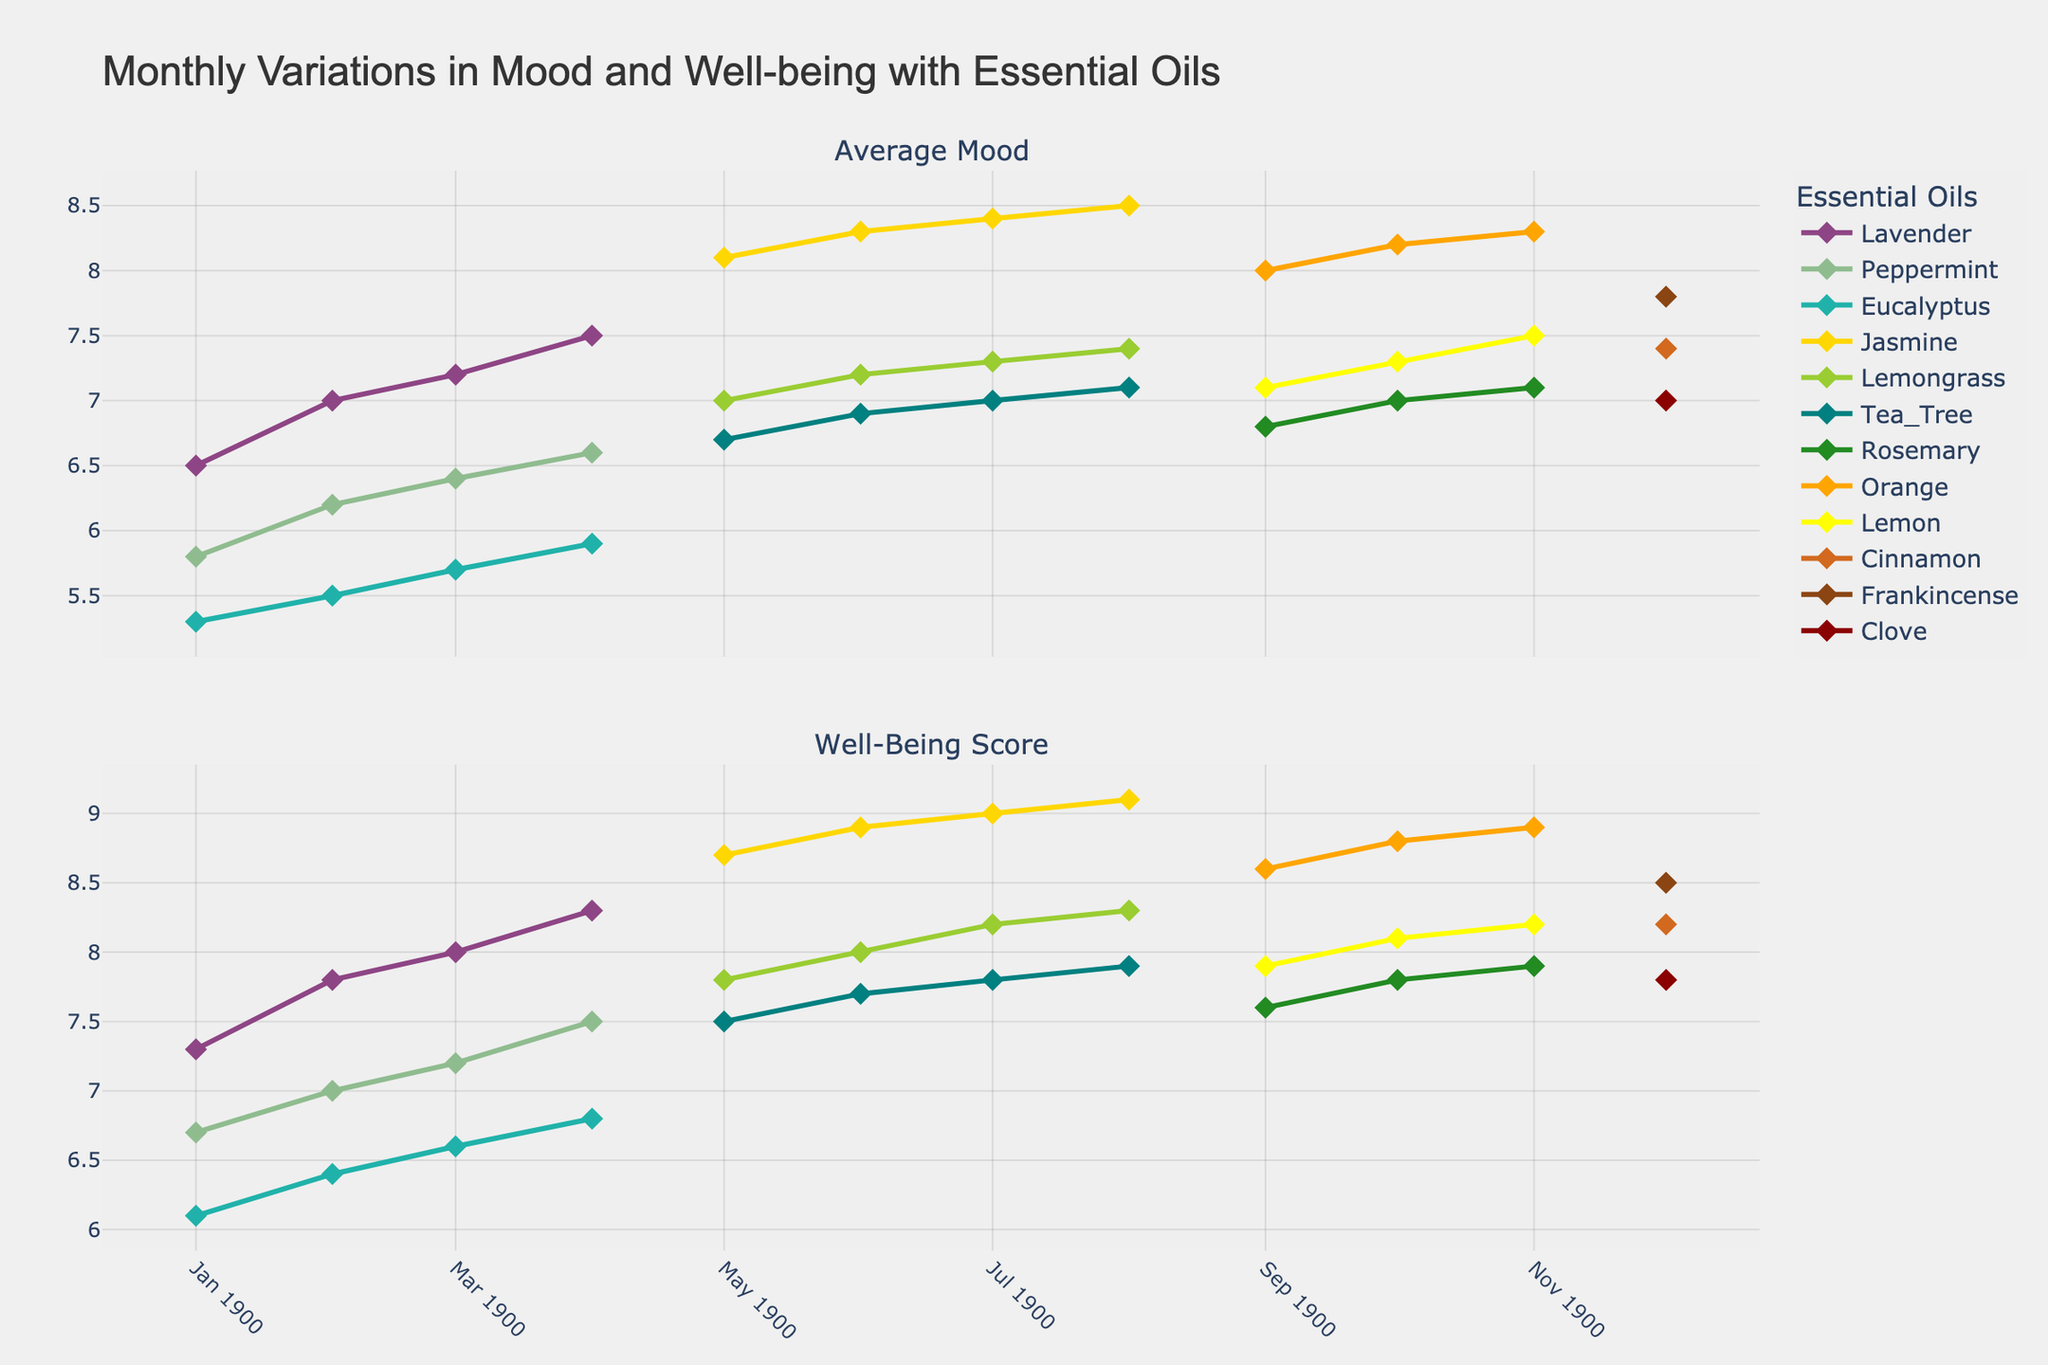Which essential oil has the highest Well-Being Score in August? To find the highest Well-Being Score in August, locate the data for August and compare the Well-Being Scores of "Jasmine," "Lemongrass," and "Tea Tree." Jasmine has the highest score at 9.1.
Answer: Jasmine How does the trend of Average Mood for "Lavender" change from January to April? Examine the line for "Lavender" in the first subplot. It starts from 6.5 in January and increases consistently to reach 7.5 in April.
Answer: It increases consistently Which month has the lowest Well-Being Score for "Eucalyptus"? Look at the Well-Being Score values for "Eucalyptus" across January, February, and March. The lowest score is 6.1 in January.
Answer: January Compare the Average Mood for "Lemon" and "Rosemary" in October. Which one is higher? Check the values for "Lemon" and "Rosemary" in October for Average Mood. "Lemon" has a value of 7.3, while "Rosemary" has 7.0. So "Lemon" is higher.
Answer: Lemon What is the difference in Well-Being Scores between "Peppermint" and "Tea Tree" in July? Find the Well-Being Scores for "Peppermint" and "Tea Tree" in July. "Peppermint" is not listed for July, so refer to the closest month, April, for "Peppermint" which is 7.5, and for "Tea Tree" in July it's 7.8. The difference is 7.8 - 7.5 = 0.3.
Answer: 0.3 Identify the month with the highest Average Mood for "Frankincense." "Frankincense" appears only in December, with an Average Mood of 7.8.
Answer: December Which essential oil shows the most significant increase in Well-Being Score from May to June? Compare the Well-Being Scores for "Jasmine," "Lemongrass," and "Tea Tree" from May to June. "Jasmine" increases from 8.7 to 8.9, "Lemongrass" from 7.8 to 8.0, and "Tea Tree" from 7.5 to 7.7. "Lemongrass" shows the largest increase, with a rise of 0.2.
Answer: Lemongrass How does the Well-Being Score for "Orange" change from September to November? The Well-Being Score for "Orange" increases from 8.6 in September to 8.8 in October, and then to 8.9 in November.
Answer: It increases consistently Is the Average Mood higher for "Cinnamon" or "Clove" in December? Look at the Average Mood for both "Cinnamon" and "Clove" in December. "Cinnamon" has 7.4 whereas "Clove" has 7.0, so "Cinnamon" is higher.
Answer: Cinnamon 